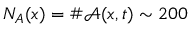Convert formula to latex. <formula><loc_0><loc_0><loc_500><loc_500>N _ { A } ( x ) = \# \mathcal { A } ( x , t ) \sim 2 0 0</formula> 